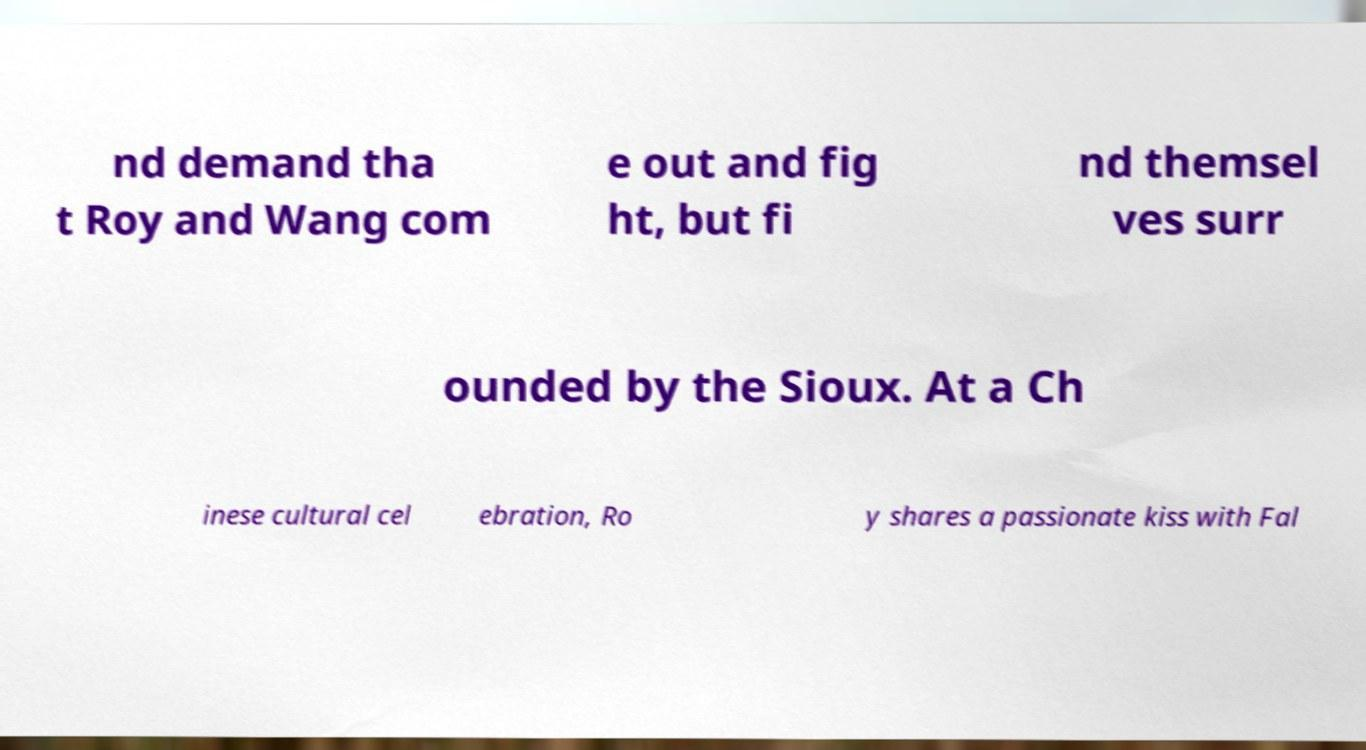Can you read and provide the text displayed in the image?This photo seems to have some interesting text. Can you extract and type it out for me? nd demand tha t Roy and Wang com e out and fig ht, but fi nd themsel ves surr ounded by the Sioux. At a Ch inese cultural cel ebration, Ro y shares a passionate kiss with Fal 